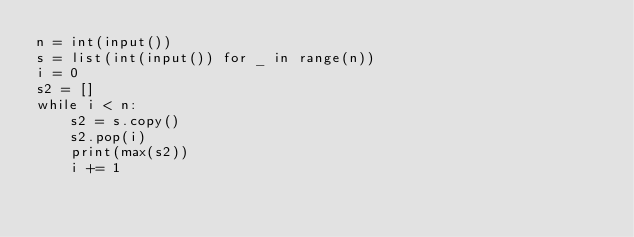Convert code to text. <code><loc_0><loc_0><loc_500><loc_500><_Python_>n = int(input())
s = list(int(input()) for _ in range(n))
i = 0
s2 = []
while i < n:
    s2 = s.copy()
    s2.pop(i)
    print(max(s2))
    i += 1
</code> 